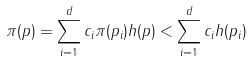Convert formula to latex. <formula><loc_0><loc_0><loc_500><loc_500>\pi ( p ) = \sum _ { i = 1 } ^ { d } c _ { i } \pi ( p _ { i } ) h ( p ) < \sum _ { i = 1 } ^ { d } c _ { i } h ( p _ { i } )</formula> 